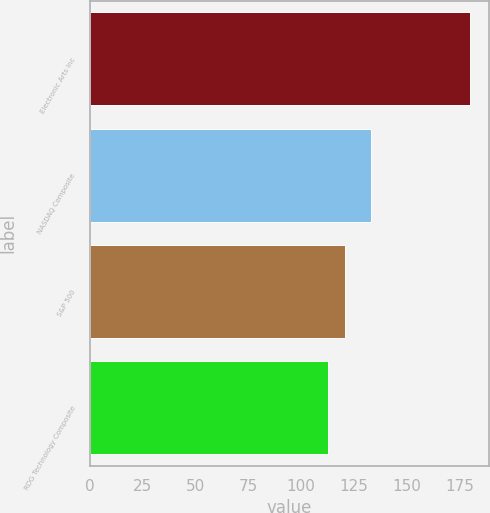<chart> <loc_0><loc_0><loc_500><loc_500><bar_chart><fcel>Electronic Arts Inc<fcel>NASDAQ Composite<fcel>S&P 500<fcel>RDG Technology Composite<nl><fcel>180<fcel>133<fcel>121<fcel>113<nl></chart> 